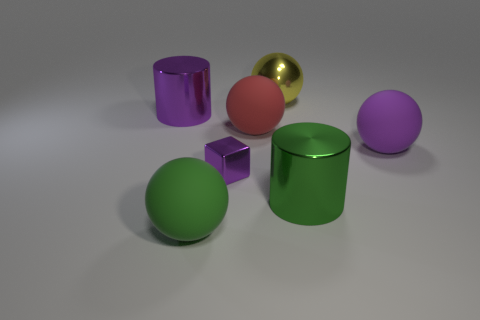There is a large shiny thing in front of the red matte sphere; what is its color? The large shiny object in front of the red matte sphere appears to be a gold or brass-colored reflective sphere. 